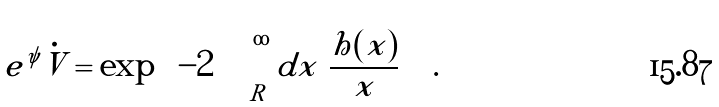Convert formula to latex. <formula><loc_0><loc_0><loc_500><loc_500>e ^ { \psi } \dot { V } = \exp \left ( - 2 \int _ { R } ^ { \infty } d x \ \frac { h ( x ) } { x } \right ) \ .</formula> 